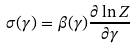Convert formula to latex. <formula><loc_0><loc_0><loc_500><loc_500>\sigma ( \gamma ) = \beta ( \gamma ) \frac { \partial \ln Z } { \partial \gamma }</formula> 